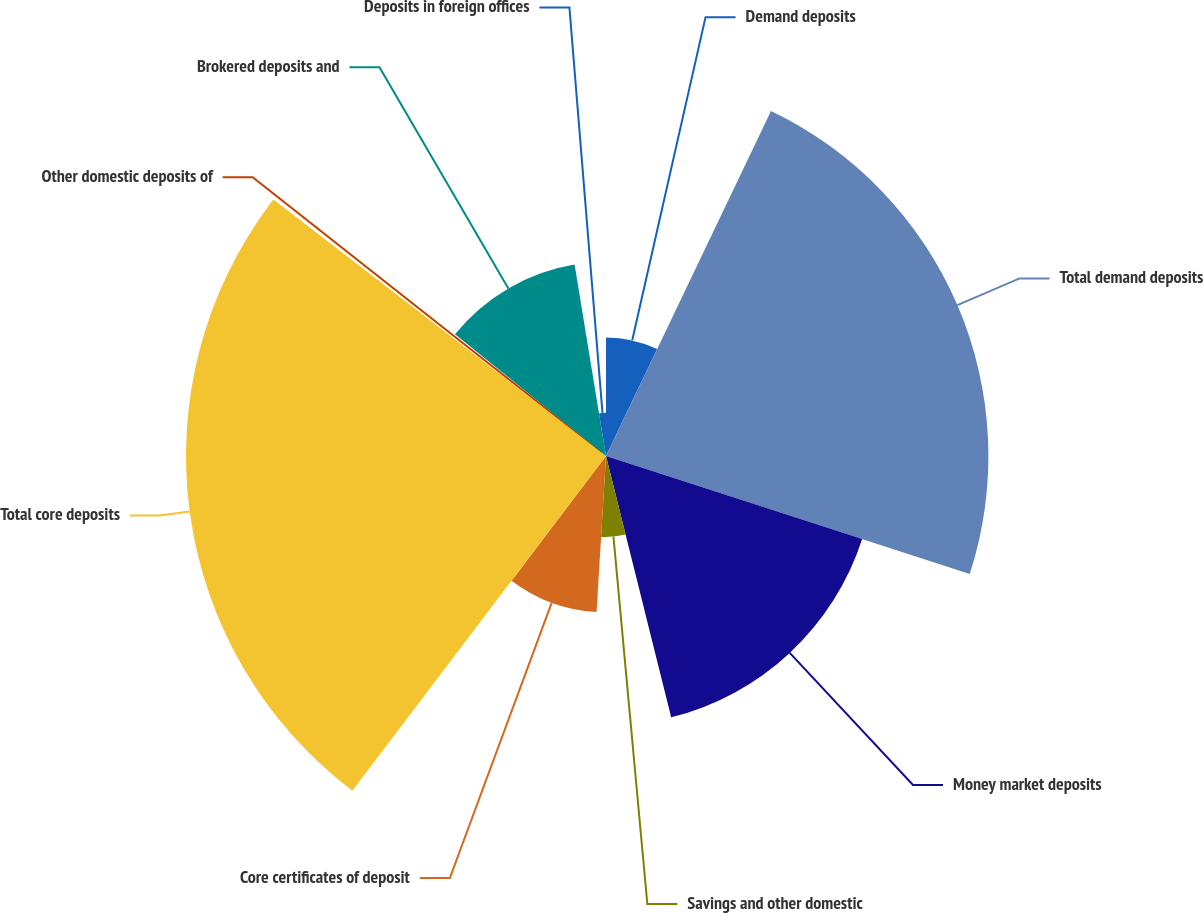Convert chart to OTSL. <chart><loc_0><loc_0><loc_500><loc_500><pie_chart><fcel>Demand deposits<fcel>Total demand deposits<fcel>Money market deposits<fcel>Savings and other domestic<fcel>Core certificates of deposit<fcel>Total core deposits<fcel>Other domestic deposits of<fcel>Brokered deposits and<fcel>Deposits in foreign offices<nl><fcel>7.1%<fcel>22.89%<fcel>16.12%<fcel>4.85%<fcel>9.36%<fcel>25.14%<fcel>0.34%<fcel>11.61%<fcel>2.59%<nl></chart> 